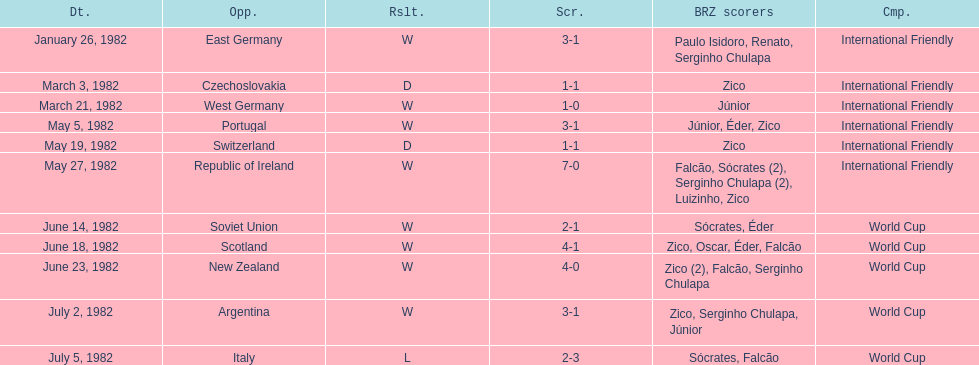What is the number of games won by brazil during the month of march 1982? 1. Help me parse the entirety of this table. {'header': ['Dt.', 'Opp.', 'Rslt.', 'Scr.', 'BRZ scorers', 'Cmp.'], 'rows': [['January 26, 1982', 'East Germany', 'W', '3-1', 'Paulo Isidoro, Renato, Serginho Chulapa', 'International Friendly'], ['March 3, 1982', 'Czechoslovakia', 'D', '1-1', 'Zico', 'International Friendly'], ['March 21, 1982', 'West Germany', 'W', '1-0', 'Júnior', 'International Friendly'], ['May 5, 1982', 'Portugal', 'W', '3-1', 'Júnior, Éder, Zico', 'International Friendly'], ['May 19, 1982', 'Switzerland', 'D', '1-1', 'Zico', 'International Friendly'], ['May 27, 1982', 'Republic of Ireland', 'W', '7-0', 'Falcão, Sócrates (2), Serginho Chulapa (2), Luizinho, Zico', 'International Friendly'], ['June 14, 1982', 'Soviet Union', 'W', '2-1', 'Sócrates, Éder', 'World Cup'], ['June 18, 1982', 'Scotland', 'W', '4-1', 'Zico, Oscar, Éder, Falcão', 'World Cup'], ['June 23, 1982', 'New Zealand', 'W', '4-0', 'Zico (2), Falcão, Serginho Chulapa', 'World Cup'], ['July 2, 1982', 'Argentina', 'W', '3-1', 'Zico, Serginho Chulapa, Júnior', 'World Cup'], ['July 5, 1982', 'Italy', 'L', '2-3', 'Sócrates, Falcão', 'World Cup']]} 